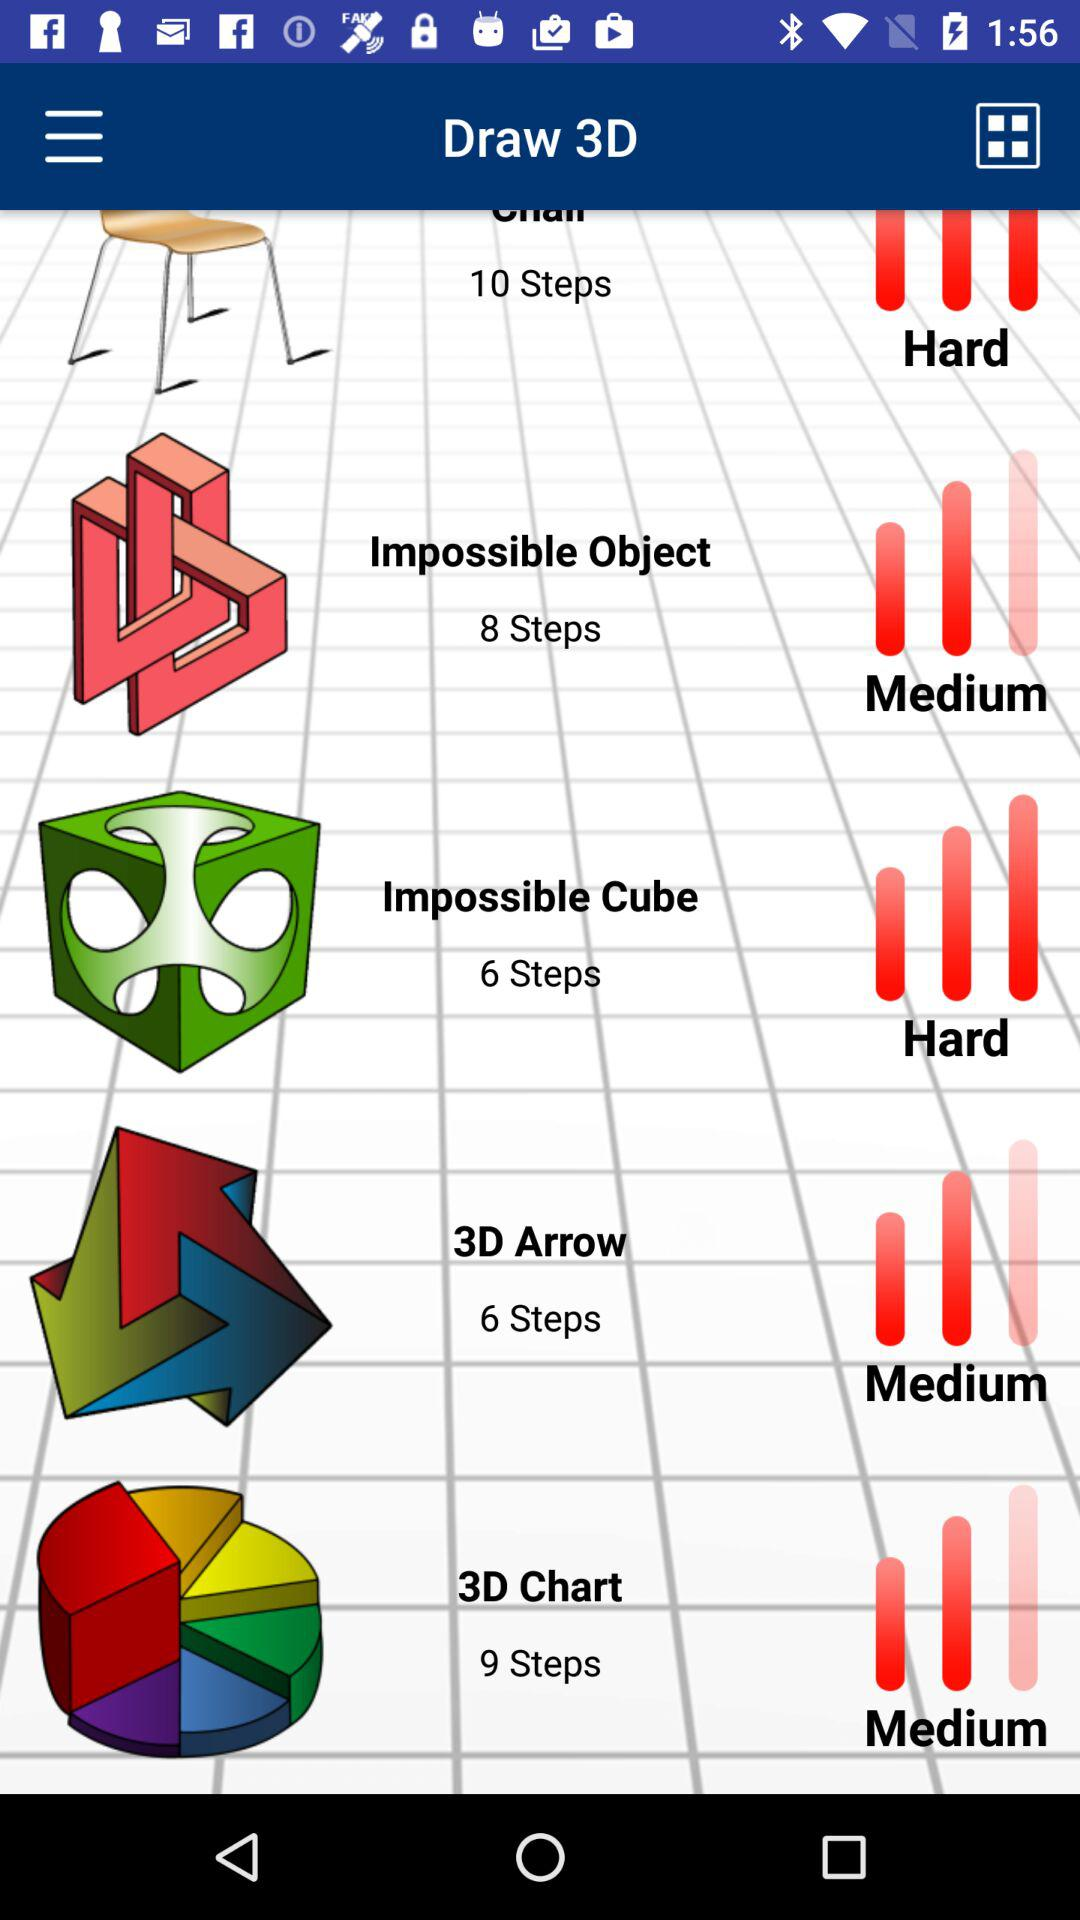What is the difficulty level to draw the "Impossible Object"? The difficulty level is medium. 